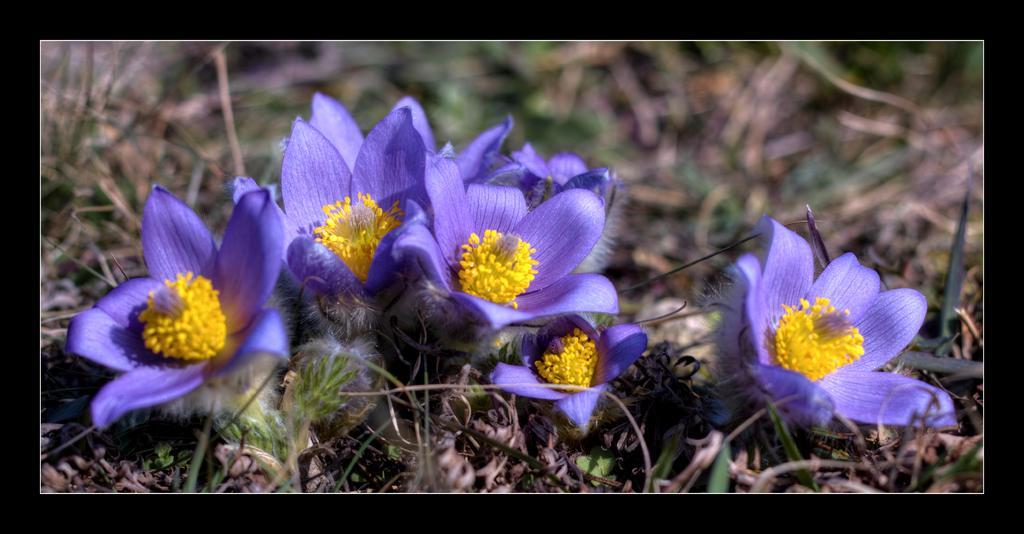Could you give a brief overview of what you see in this image? In this image we can see flowers and grass on the ground. 